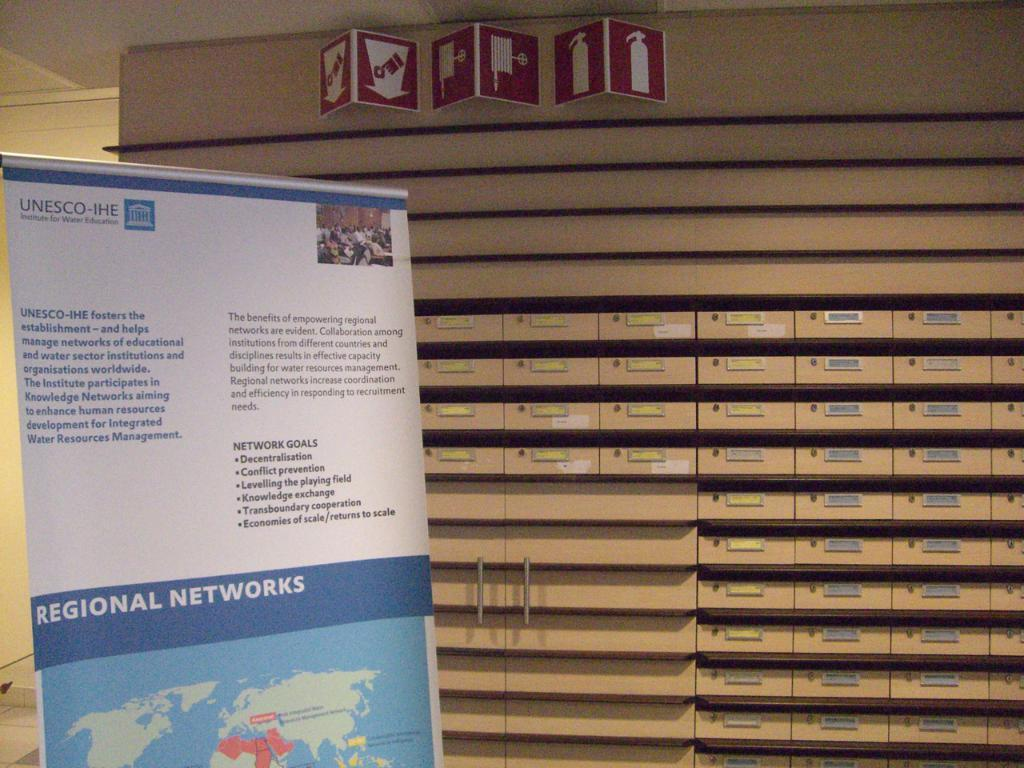<image>
Share a concise interpretation of the image provided. A flyer by UNESC-IHE Institute for Water Education has a map at the bottom of the page. 